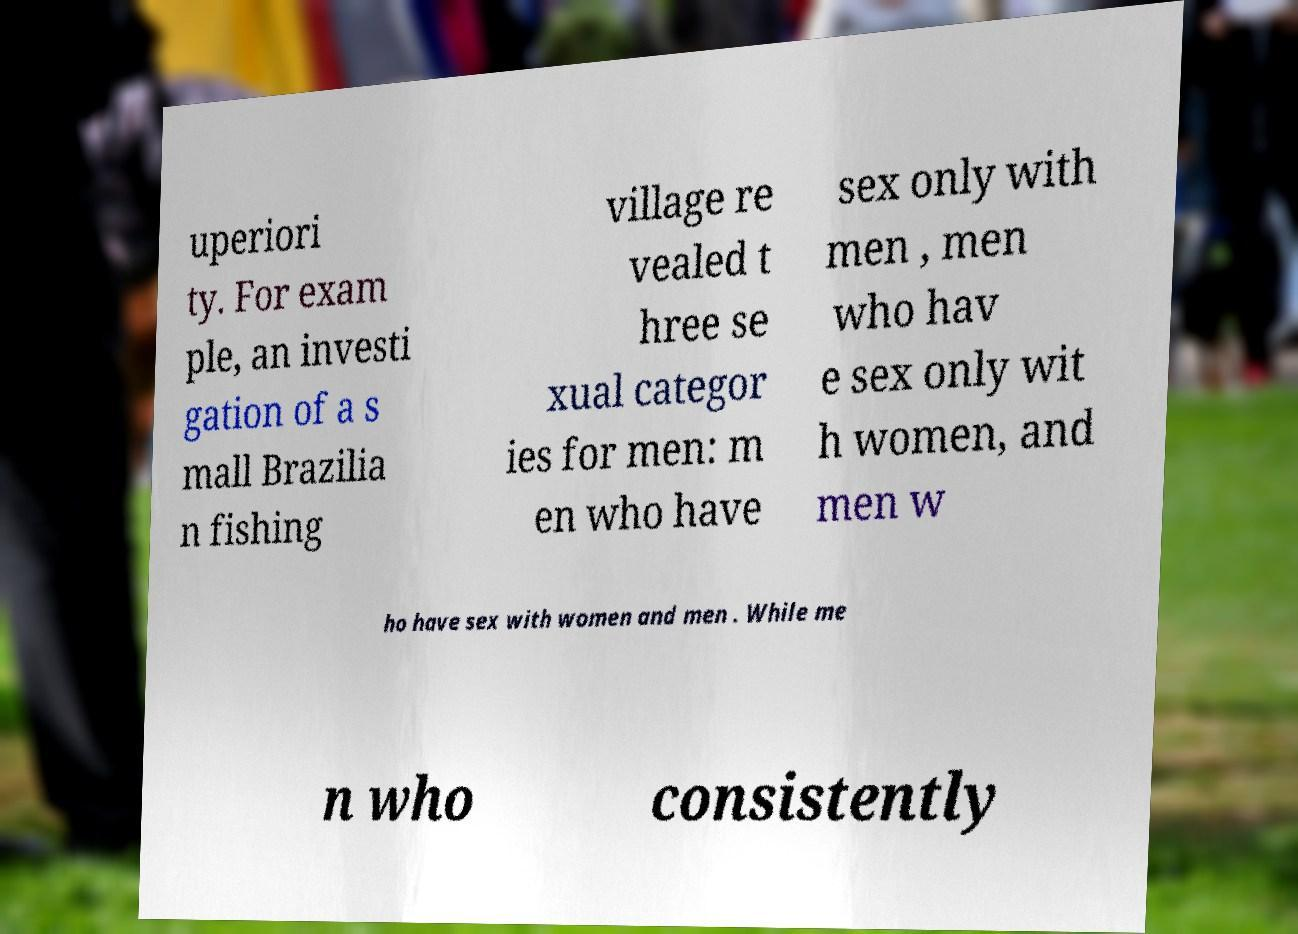I need the written content from this picture converted into text. Can you do that? uperiori ty. For exam ple, an investi gation of a s mall Brazilia n fishing village re vealed t hree se xual categor ies for men: m en who have sex only with men , men who hav e sex only wit h women, and men w ho have sex with women and men . While me n who consistently 